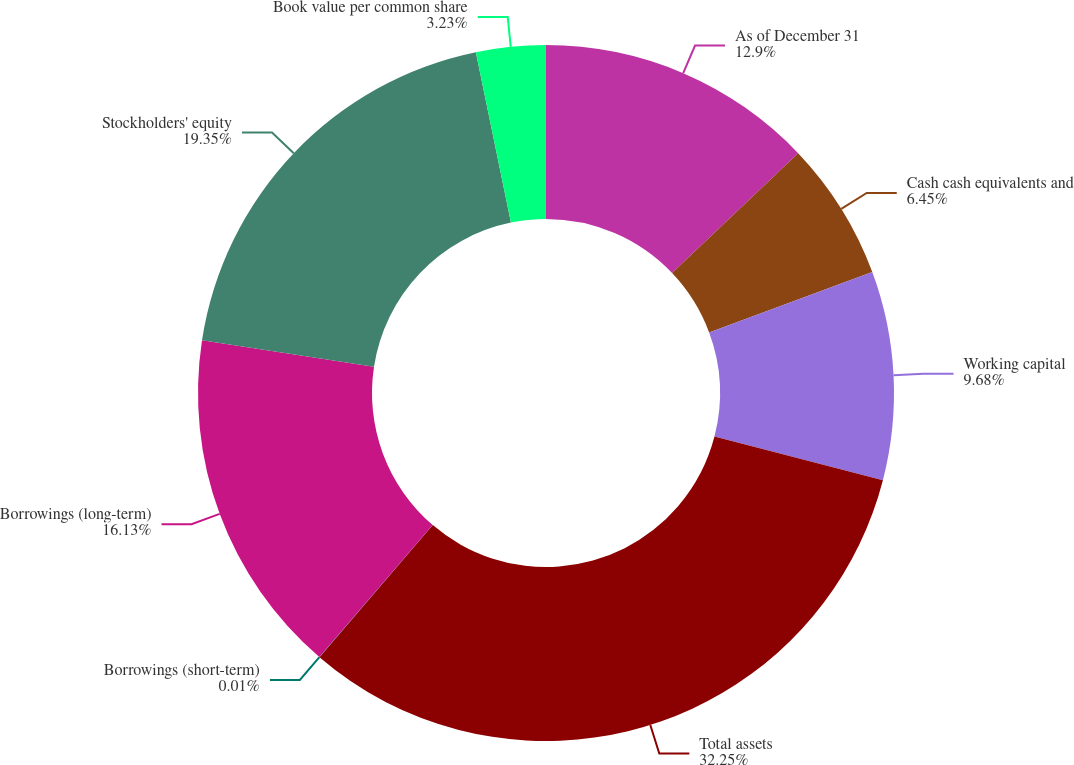Convert chart. <chart><loc_0><loc_0><loc_500><loc_500><pie_chart><fcel>As of December 31<fcel>Cash cash equivalents and<fcel>Working capital<fcel>Total assets<fcel>Borrowings (short-term)<fcel>Borrowings (long-term)<fcel>Stockholders' equity<fcel>Book value per common share<nl><fcel>12.9%<fcel>6.45%<fcel>9.68%<fcel>32.25%<fcel>0.01%<fcel>16.13%<fcel>19.35%<fcel>3.23%<nl></chart> 